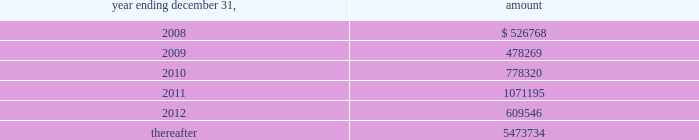Vornado realty trust notes to consolidated financial statements ( continued ) 9 .
Debt - continued our revolving credit facility and senior unsecured notes contain financial covenants which require us to maintain minimum interest coverage ratios and limit our debt to market capitalization ratios .
We believe that we have complied with all of our financial covenants as of december 31 , 2007 .
On may 9 , 2006 , we executed supplemental indentures with respect to our senior unsecured notes due 2007 , 2009 and 2010 ( collectively , the 201cnotes 201d ) , pursuant to our consent solicitation statement dated april 18 , 2006 , as amended .
Holders of approximately 96.7% ( 96.7 % ) of the aggregate principal amount of the notes consented to the solicitation .
The supplemental indentures contain modifications of certain covenants and related defined terms governing the terms of the notes to make them consistent with corresponding provisions of the covenants and defined terms included in the senior unsecured notes due 2011 issued on february 16 , 2006 .
The supplemental indentures also include a new covenant that provides for an increase in the interest rate of the notes upon certain decreases in the ratings assigned by rating agencies to the notes .
In connection with the consent solicitation we paid an aggregate fee of $ 2241000 to the consenting note holders , which will be amortized into expense over the remaining term of the notes .
In addition , we incurred advisory and professional fees aggregating $ 1415000 , which were expensed in 2006 .
The net carrying amount of properties collateralizing the notes and mortgages payable amounted to $ 10.920 billion at december 31 , 2007 .
As at december 31 , 2007 , the principal repayments required for the next five years and thereafter are as follows : ( amounts in thousands ) .

For the year ending december 31 , 2008 , were principal payments greater than 2009? 
Computations: (526768 > 478269)
Answer: yes. 